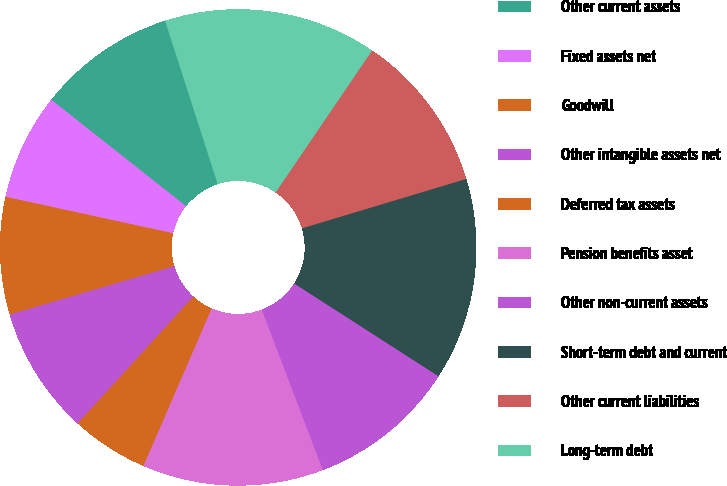Convert chart. <chart><loc_0><loc_0><loc_500><loc_500><pie_chart><fcel>Other current assets<fcel>Fixed assets net<fcel>Goodwill<fcel>Other intangible assets net<fcel>Deferred tax assets<fcel>Pension benefits asset<fcel>Other non-current assets<fcel>Short-term debt and current<fcel>Other current liabilities<fcel>Long-term debt<nl><fcel>9.4%<fcel>7.23%<fcel>7.96%<fcel>8.68%<fcel>5.26%<fcel>12.29%<fcel>10.12%<fcel>13.74%<fcel>10.85%<fcel>14.46%<nl></chart> 